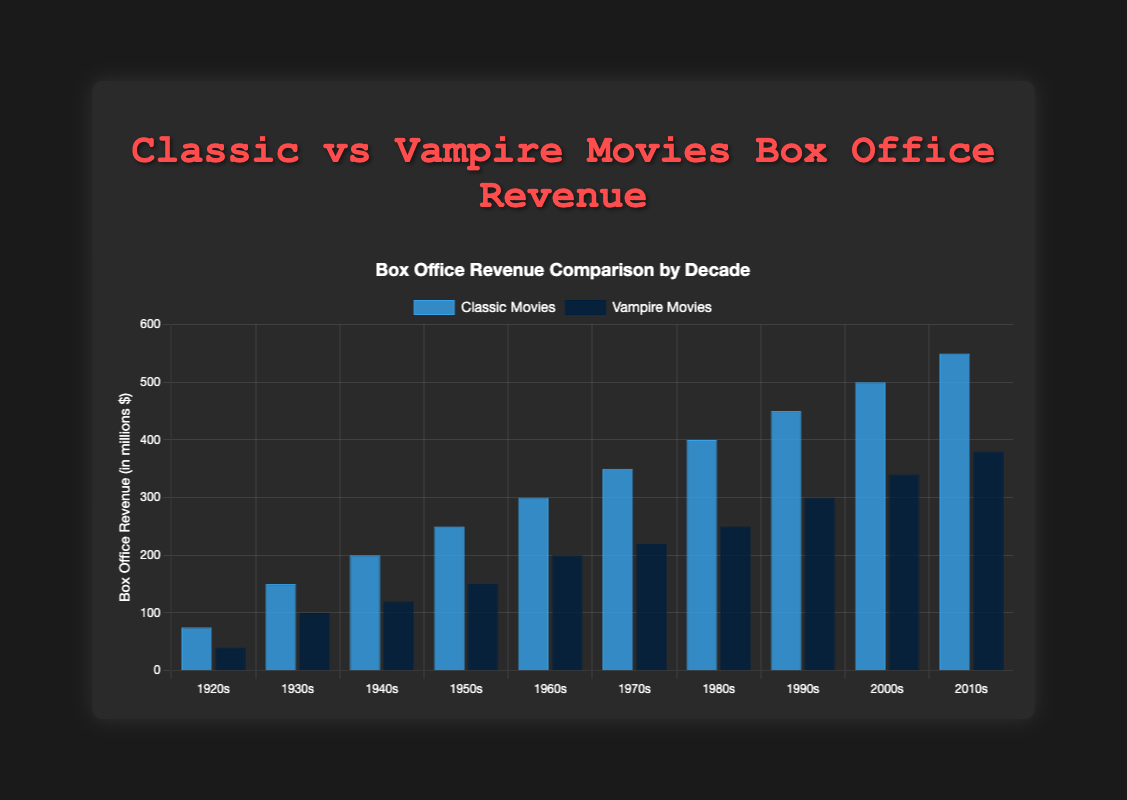Which decade had the highest box office revenue for classic movies? Look at the heights of the blue bars representing classic movies. The highest bar corresponds to the 2010s.
Answer: 2010s Which decade had the lowest box office revenue for vampire movies? Look at the heights of the dark blue bars representing vampire movies. The lowest bar corresponds to the 1920s.
Answer: 1920s How much more revenue did classic movies make compared to vampire movies in the 1960s? Identify the revenue of classic movies (300) and vampire movies (200) in the 1960s and calculate the difference (300 - 200).
Answer: 100 million dollars In which decade did both classic and vampire movies see an increase in box office revenue compared to the previous decade? Identify increases by comparing the heights of each bar with its predecessor for both datasets. The 1930s and 1940s bars for both genres increase compared to the 1920s and 1930s respectively.
Answer: 1930s, 1940s What is the average box office revenue for vampire movies over the decades? Sum the revenues for vampire movies (40 + 100 + 120 + 150 + 200 + 220 + 250 + 300 + 340 + 380) = 2100. Divide by the number of decades (10). 2100/10 = 210.
Answer: 210 million dollars What decade saw the largest increase in box office revenue for vampire movies compared to the previous decade? Calculate the difference in height between consecutive dark blue bars to find the maximum increase. The largest increase (60) is between the 1920s (40) and 1930s (100).
Answer: 1930s What is the combined box office revenue of classic and vampire movies in the 1990s? Add the revenues for both genres in the 1990s: classic movies (450) + vampire movies (300) = 750.
Answer: 750 million dollars Which genre had a higher box office revenue in the 1980s and by how much? Compare the heights of the blue bar (classic movies, 400) and the dark blue bar (vampire movies, 250) in the 1980s. Calculate the difference (400 - 250).
Answer: Classic movies by 150 million dollars 